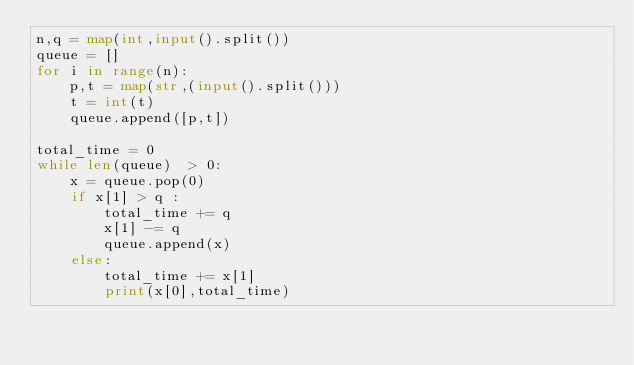<code> <loc_0><loc_0><loc_500><loc_500><_Python_>n,q = map(int,input().split())
queue = []
for i in range(n):
    p,t = map(str,(input().split()))
    t = int(t)
    queue.append([p,t])

total_time = 0
while len(queue)  > 0:
    x = queue.pop(0)
    if x[1] > q :
        total_time += q
        x[1] -= q
        queue.append(x)
    else:
        total_time += x[1]
        print(x[0],total_time)</code> 